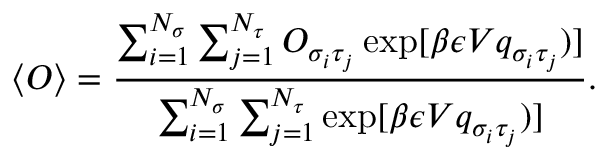Convert formula to latex. <formula><loc_0><loc_0><loc_500><loc_500>\langle O \rangle = \frac { \sum _ { i = 1 } ^ { N _ { \sigma } } \sum _ { j = 1 } ^ { N _ { \tau } } O _ { \sigma _ { i } \tau _ { j } } \exp [ \beta \epsilon V q _ { \sigma _ { i } \tau _ { j } } ) ] } { \sum _ { i = 1 } ^ { N _ { \sigma } } \sum _ { j = 1 } ^ { N _ { \tau } } \exp [ \beta \epsilon V q _ { \sigma _ { i } \tau _ { j } } ) ] } .</formula> 